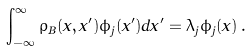<formula> <loc_0><loc_0><loc_500><loc_500>\int _ { - \infty } ^ { \infty } \rho _ { B } ( x , x ^ { \prime } ) \phi _ { j } ( x ^ { \prime } ) d x ^ { \prime } = \lambda _ { j } \phi _ { j } ( x ) \, .</formula> 